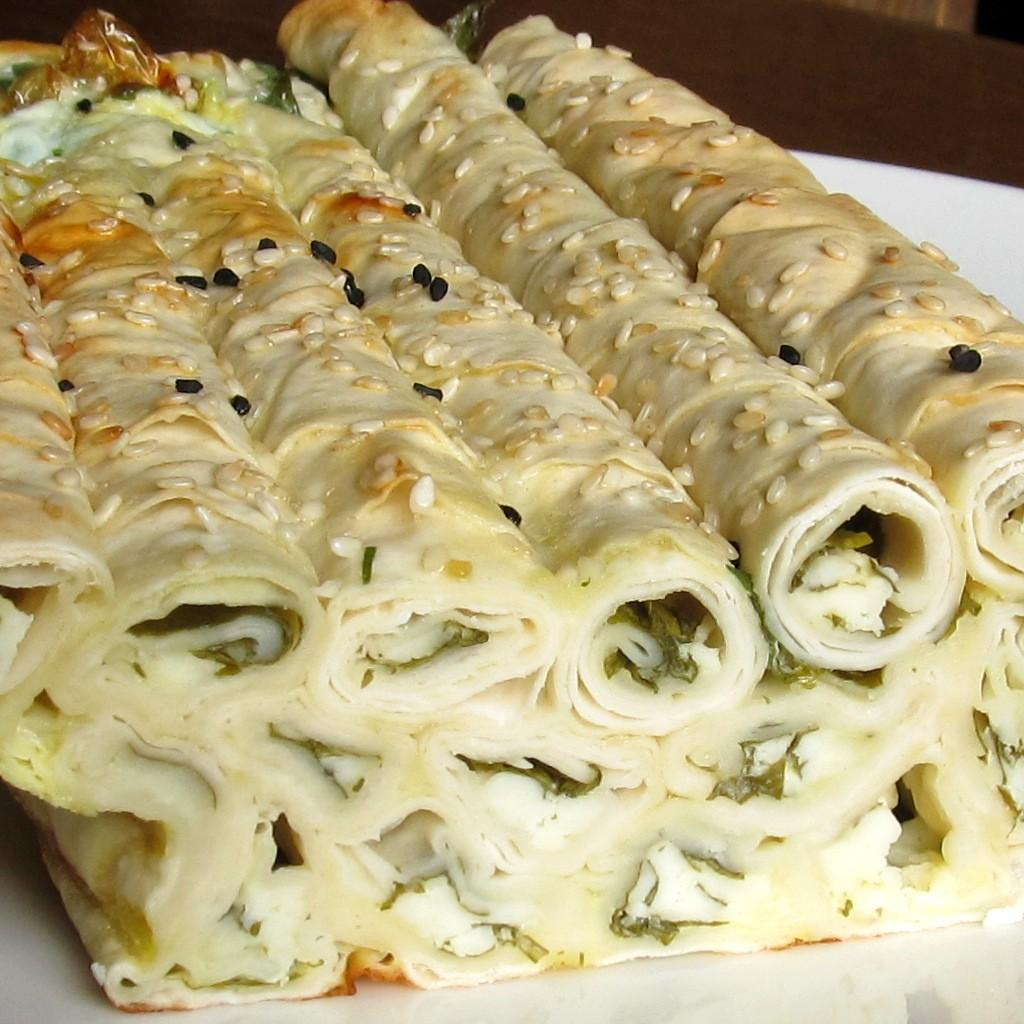What is present in the image related to food? There is food in the image. How is the food arranged or contained? The food is in a plate. Where is the plate with food located? The plate is on a platform. What type of pain is the tree experiencing in the image? There is no tree present in the image, so it is not possible to determine if a tree is experiencing any pain. 